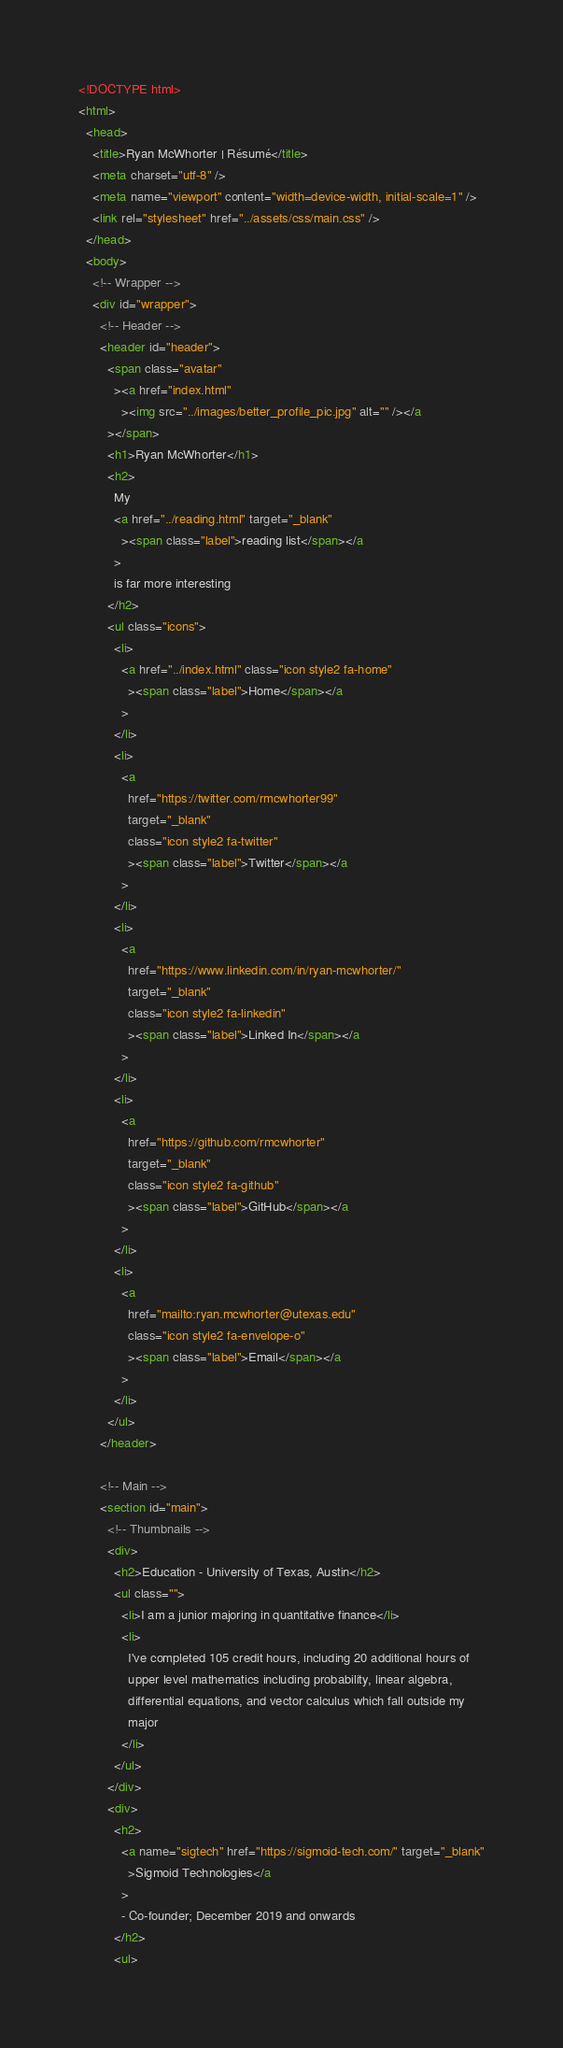<code> <loc_0><loc_0><loc_500><loc_500><_HTML_><!DOCTYPE html>
<html>
  <head>
    <title>Ryan McWhorter | Résumé</title>
    <meta charset="utf-8" />
    <meta name="viewport" content="width=device-width, initial-scale=1" />
    <link rel="stylesheet" href="../assets/css/main.css" />
  </head>
  <body>
    <!-- Wrapper -->
    <div id="wrapper">
      <!-- Header -->
      <header id="header">
        <span class="avatar"
          ><a href="index.html"
            ><img src="../images/better_profile_pic.jpg" alt="" /></a
        ></span>
        <h1>Ryan McWhorter</h1>
        <h2>
          My
          <a href="../reading.html" target="_blank"
            ><span class="label">reading list</span></a
          >
          is far more interesting
        </h2>
        <ul class="icons">
          <li>
            <a href="../index.html" class="icon style2 fa-home"
              ><span class="label">Home</span></a
            >
          </li>
          <li>
            <a
              href="https://twitter.com/rmcwhorter99"
              target="_blank"
              class="icon style2 fa-twitter"
              ><span class="label">Twitter</span></a
            >
          </li>
          <li>
            <a
              href="https://www.linkedin.com/in/ryan-mcwhorter/"
              target="_blank"
              class="icon style2 fa-linkedin"
              ><span class="label">Linked In</span></a
            >
          </li>
          <li>
            <a
              href="https://github.com/rmcwhorter"
              target="_blank"
              class="icon style2 fa-github"
              ><span class="label">GitHub</span></a
            >
          </li>
          <li>
            <a
              href="mailto:ryan.mcwhorter@utexas.edu"
              class="icon style2 fa-envelope-o"
              ><span class="label">Email</span></a
            >
          </li>
        </ul>
      </header>

      <!-- Main -->
      <section id="main">
        <!-- Thumbnails -->
        <div>
          <h2>Education - University of Texas, Austin</h2>
          <ul class="">
            <li>I am a junior majoring in quantitative finance</li>
            <li>
              I've completed 105 credit hours, including 20 additional hours of
              upper level mathematics including probability, linear algebra,
              differential equations, and vector calculus which fall outside my
              major
            </li>
          </ul>
        </div>
        <div>
          <h2>
            <a name="sigtech" href="https://sigmoid-tech.com/" target="_blank"
              >Sigmoid Technologies</a
            >
            - Co-founder; December 2019 and onwards
          </h2>
          <ul></code> 